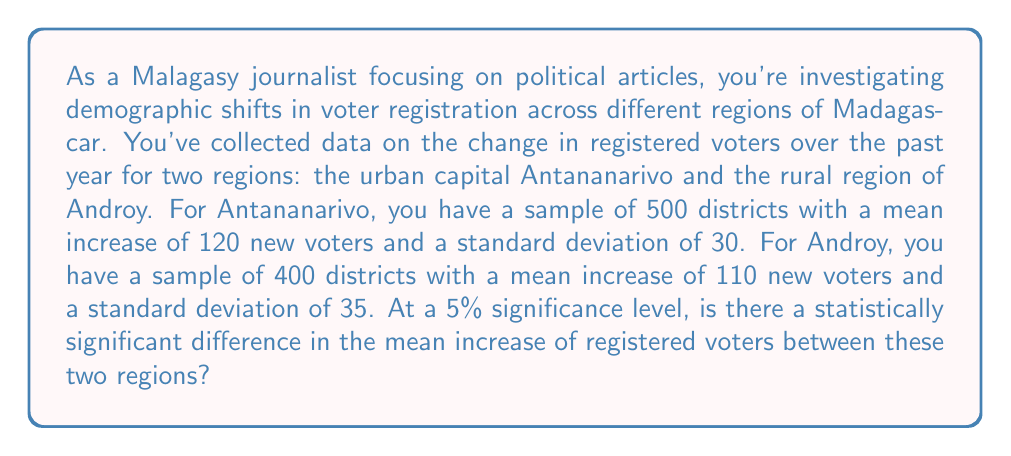Can you answer this question? To determine if there's a statistically significant difference between the mean increase of registered voters in Antananarivo and Androy, we'll use a two-sample t-test. We'll follow these steps:

1. State the null and alternative hypotheses:
   $H_0: \mu_1 - \mu_2 = 0$ (no difference in means)
   $H_a: \mu_1 - \mu_2 \neq 0$ (there is a difference in means)

2. Calculate the pooled standard error:
   $$SE = \sqrt{\frac{s_1^2}{n_1} + \frac{s_2^2}{n_2}}$$
   where $s_1$ and $s_2$ are the sample standard deviations, and $n_1$ and $n_2$ are the sample sizes.

   $$SE = \sqrt{\frac{30^2}{500} + \frac{35^2}{400}} = \sqrt{1.8 + 3.0625} = \sqrt{4.8625} \approx 2.2051$$

3. Calculate the t-statistic:
   $$t = \frac{(\bar{x}_1 - \bar{x}_2) - (\mu_1 - \mu_2)}{SE}$$
   where $\bar{x}_1$ and $\bar{x}_2$ are the sample means, and $(\mu_1 - \mu_2) = 0$ under the null hypothesis.

   $$t = \frac{(120 - 110) - 0}{2.2051} = \frac{10}{2.2051} \approx 4.5349$$

4. Calculate the degrees of freedom (df) using the Welch–Satterthwaite equation:
   $$df = \frac{(s_1^2/n_1 + s_2^2/n_2)^2}{(s_1^2/n_1)^2/(n_1-1) + (s_2^2/n_2)^2/(n_2-1)}$$

   $$df \approx 811.76$$ (rounded to 812)

5. Find the critical t-value for a two-tailed test at α = 0.05 and df = 812:
   $t_{crit} \approx \pm 1.9631$

6. Compare the calculated t-statistic to the critical t-value:
   $|4.5349| > 1.9631$

7. Calculate the p-value:
   $p < 0.0001$ (using a t-distribution calculator)

Since the absolute value of our calculated t-statistic (4.5349) is greater than the critical t-value (1.9631), and the p-value (< 0.0001) is less than our significance level (0.05), we reject the null hypothesis.
Answer: Yes, there is a statistically significant difference in the mean increase of registered voters between Antananarivo and Androy at the 5% significance level (t ≈ 4.5349, df ≈ 812, p < 0.0001). 